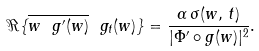Convert formula to latex. <formula><loc_0><loc_0><loc_500><loc_500>\Re \{ \overline { w \ g ^ { \prime } ( w ) } \ g _ { t } ( w ) \} = \frac { \alpha \, \sigma ( w , \, t ) } { | \Phi ^ { \prime } \circ g ( w ) | ^ { 2 } } .</formula> 